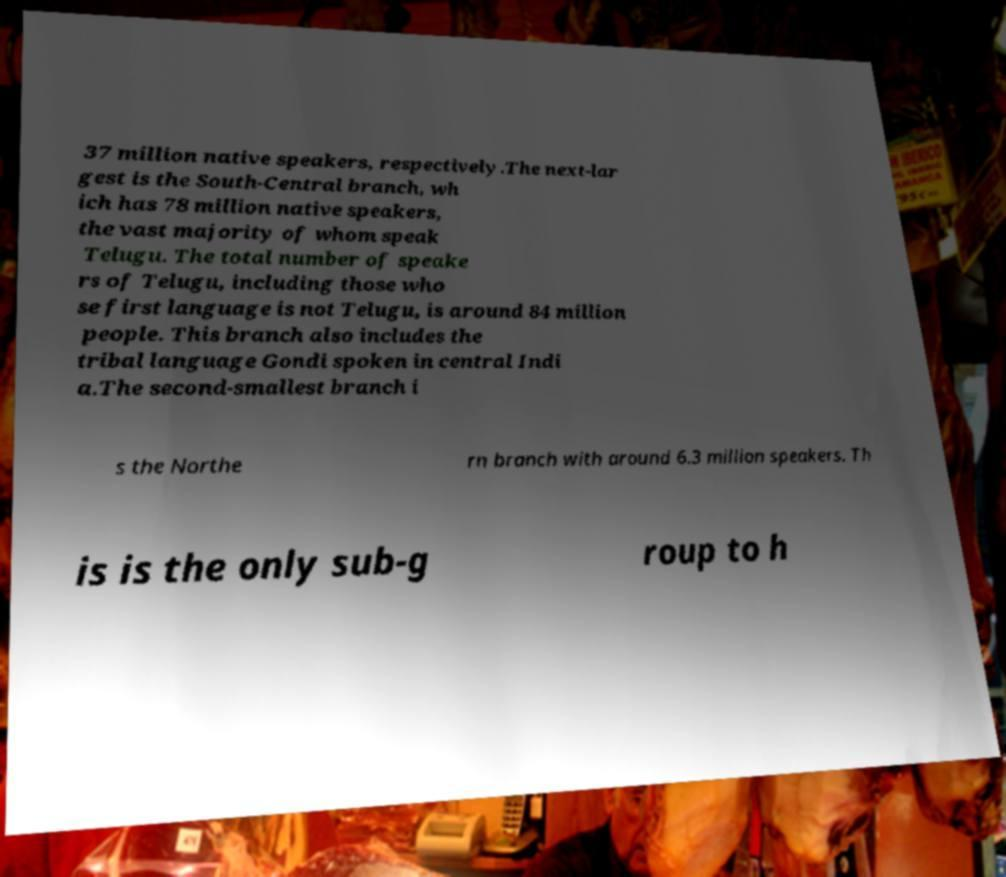There's text embedded in this image that I need extracted. Can you transcribe it verbatim? 37 million native speakers, respectively.The next-lar gest is the South-Central branch, wh ich has 78 million native speakers, the vast majority of whom speak Telugu. The total number of speake rs of Telugu, including those who se first language is not Telugu, is around 84 million people. This branch also includes the tribal language Gondi spoken in central Indi a.The second-smallest branch i s the Northe rn branch with around 6.3 million speakers. Th is is the only sub-g roup to h 